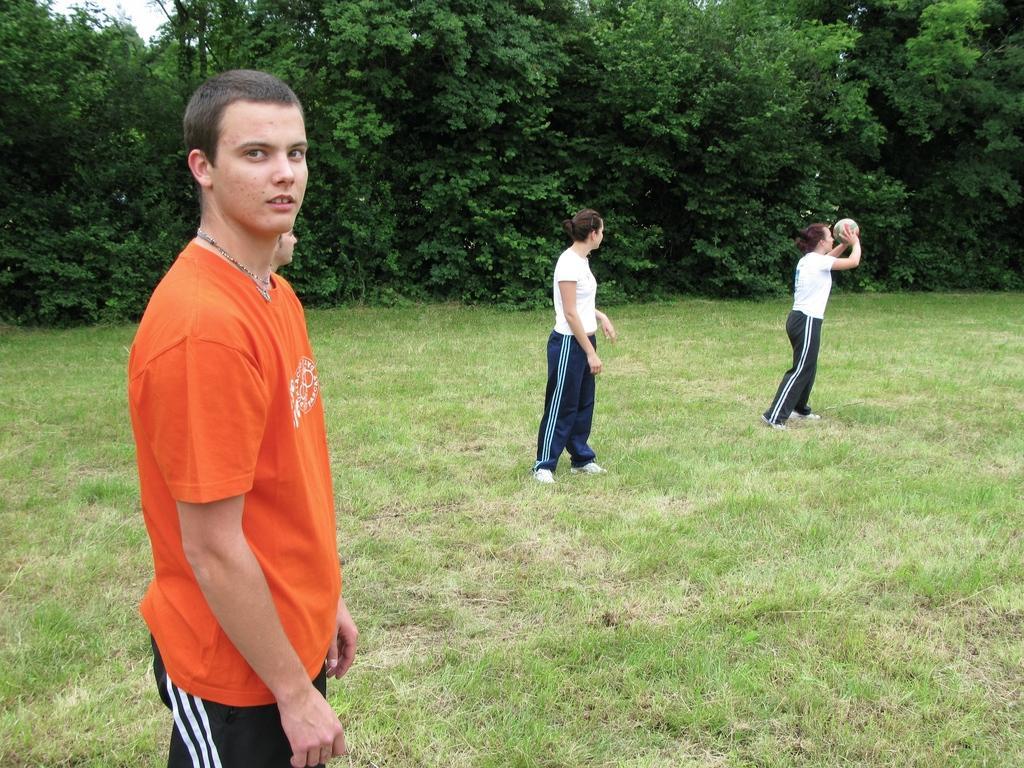In one or two sentences, can you explain what this image depicts? There are four people standing. This woman is holding a ball. Here is the grass. These are the trees with branches and leaves. 